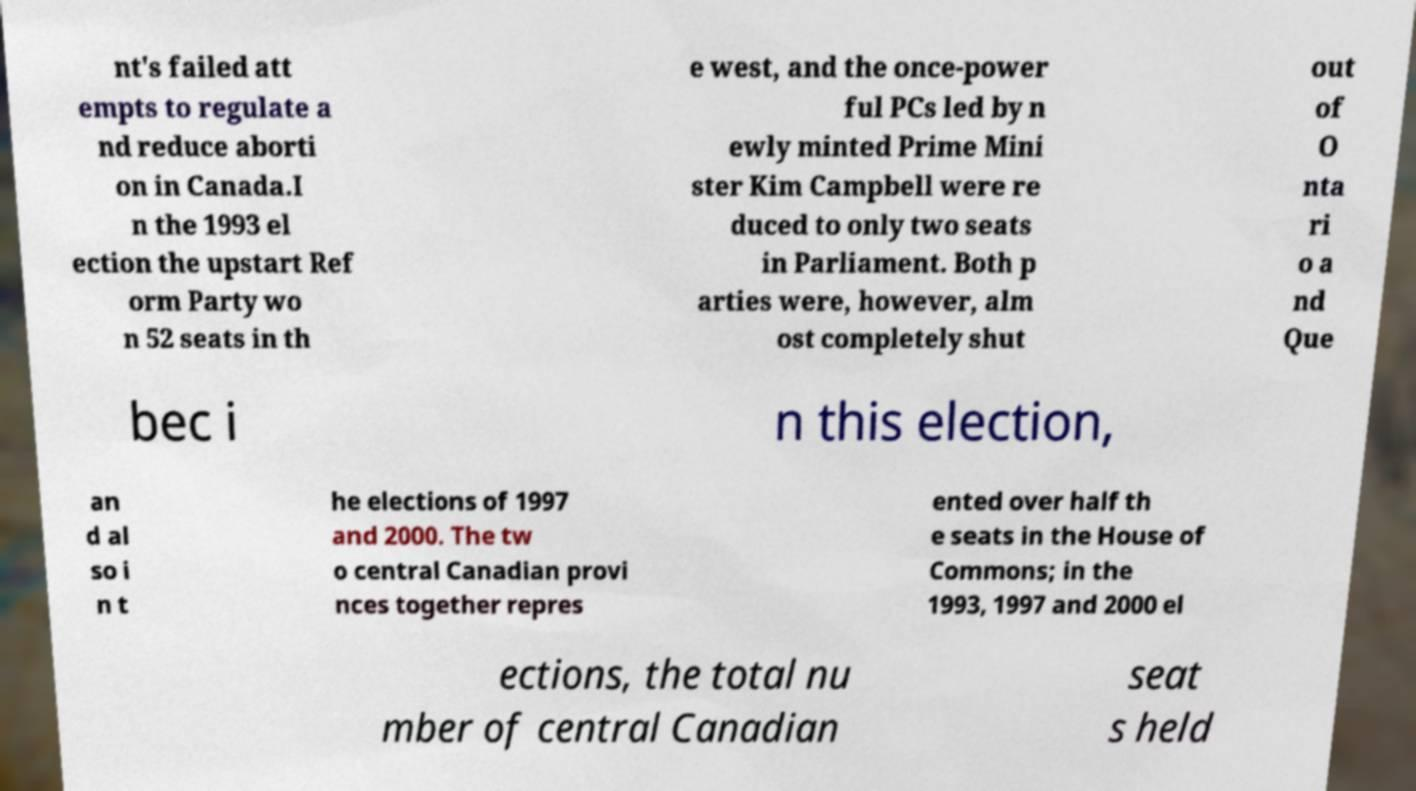There's text embedded in this image that I need extracted. Can you transcribe it verbatim? nt's failed att empts to regulate a nd reduce aborti on in Canada.I n the 1993 el ection the upstart Ref orm Party wo n 52 seats in th e west, and the once-power ful PCs led by n ewly minted Prime Mini ster Kim Campbell were re duced to only two seats in Parliament. Both p arties were, however, alm ost completely shut out of O nta ri o a nd Que bec i n this election, an d al so i n t he elections of 1997 and 2000. The tw o central Canadian provi nces together repres ented over half th e seats in the House of Commons; in the 1993, 1997 and 2000 el ections, the total nu mber of central Canadian seat s held 